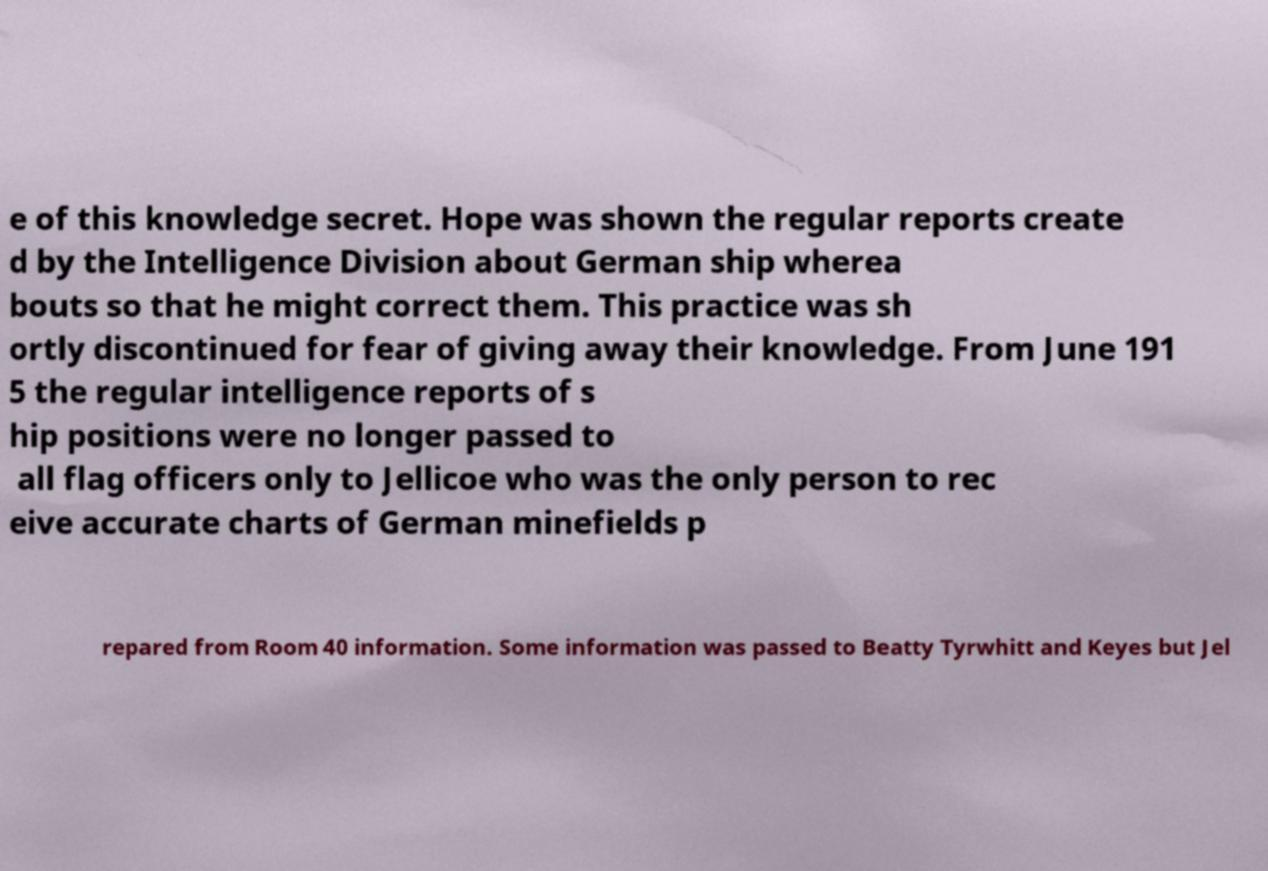Could you extract and type out the text from this image? e of this knowledge secret. Hope was shown the regular reports create d by the Intelligence Division about German ship wherea bouts so that he might correct them. This practice was sh ortly discontinued for fear of giving away their knowledge. From June 191 5 the regular intelligence reports of s hip positions were no longer passed to all flag officers only to Jellicoe who was the only person to rec eive accurate charts of German minefields p repared from Room 40 information. Some information was passed to Beatty Tyrwhitt and Keyes but Jel 